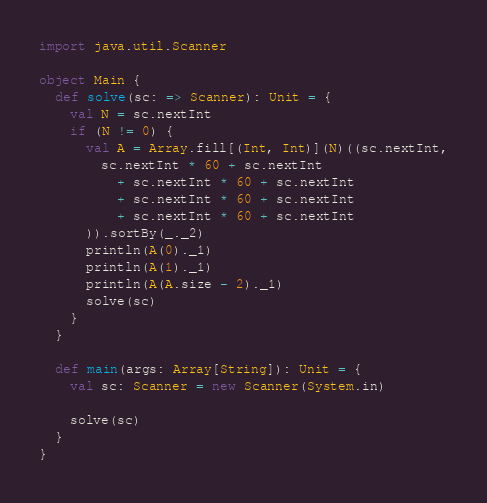<code> <loc_0><loc_0><loc_500><loc_500><_Scala_>import java.util.Scanner

object Main {
  def solve(sc: => Scanner): Unit = {
    val N = sc.nextInt
    if (N != 0) {
      val A = Array.fill[(Int, Int)](N)((sc.nextInt,
        sc.nextInt * 60 + sc.nextInt
          + sc.nextInt * 60 + sc.nextInt
          + sc.nextInt * 60 + sc.nextInt
          + sc.nextInt * 60 + sc.nextInt
      )).sortBy(_._2)
      println(A(0)._1)
      println(A(1)._1)
      println(A(A.size - 2)._1)
      solve(sc)
    }
  }

  def main(args: Array[String]): Unit = {
    val sc: Scanner = new Scanner(System.in)

    solve(sc)
  }
}</code> 